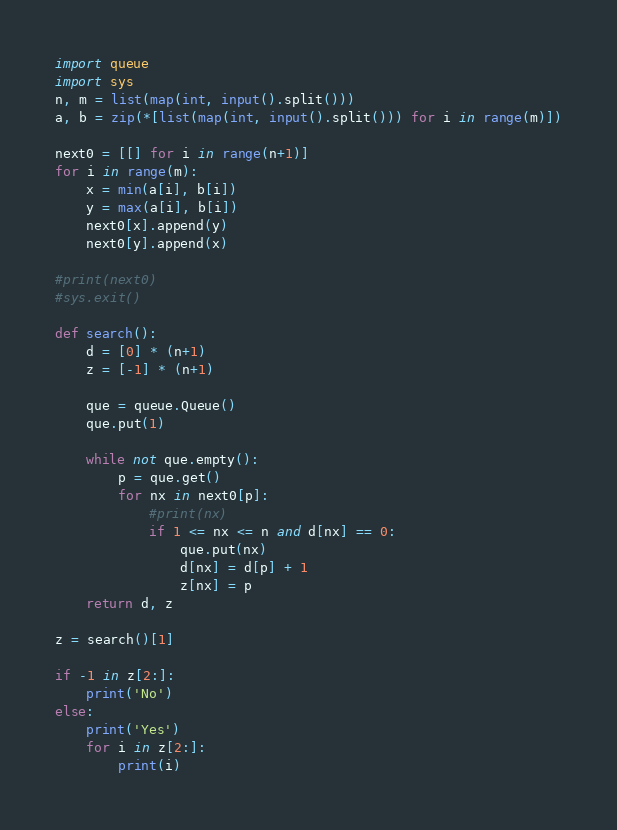<code> <loc_0><loc_0><loc_500><loc_500><_Python_>import queue
import sys
n, m = list(map(int, input().split()))
a, b = zip(*[list(map(int, input().split())) for i in range(m)])

next0 = [[] for i in range(n+1)]
for i in range(m):
    x = min(a[i], b[i])
    y = max(a[i], b[i])
    next0[x].append(y)
    next0[y].append(x)

#print(next0)
#sys.exit()

def search():
    d = [0] * (n+1)
    z = [-1] * (n+1)

    que = queue.Queue()
    que.put(1)

    while not que.empty():
        p = que.get()
        for nx in next0[p]:
            #print(nx)
            if 1 <= nx <= n and d[nx] == 0:
                que.put(nx)
                d[nx] = d[p] + 1
                z[nx] = p
    return d, z

z = search()[1]

if -1 in z[2:]:
    print('No')
else:
    print('Yes')
    for i in z[2:]:
        print(i)</code> 